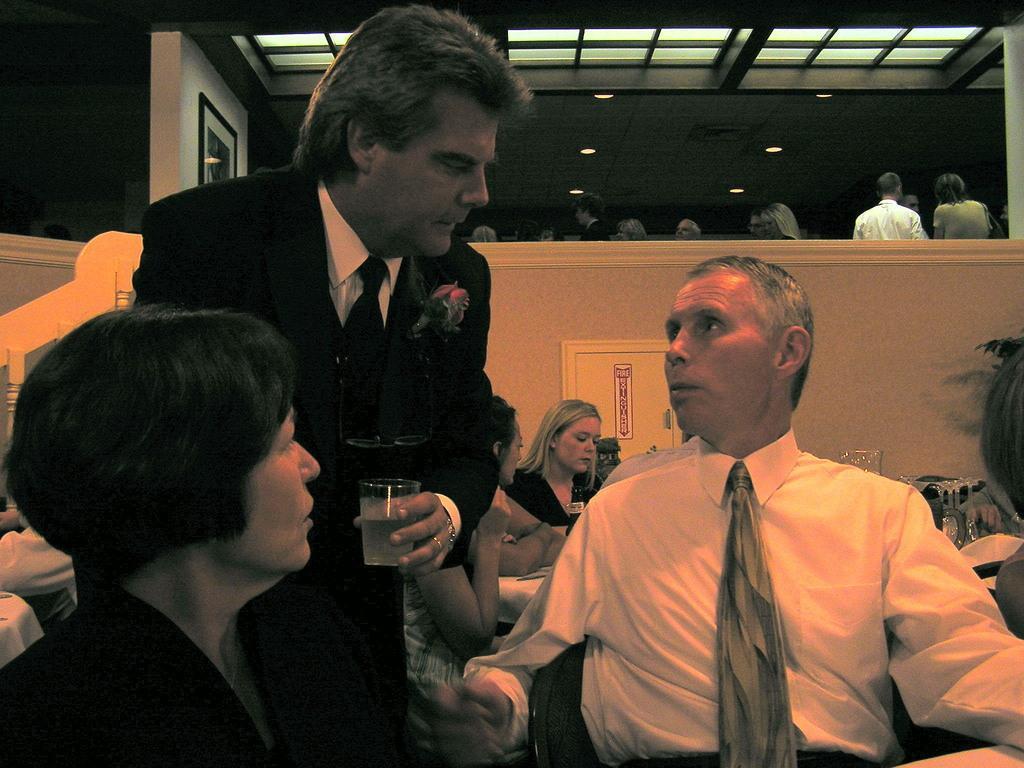Can you describe this image briefly? In the picture we can see a man and a woman sitting on the chairs and between them we can see a man standing and holding a glass with water and he is in blazer, tie and shirt and a man who is sitting looking at him and behind them, we can see some women are also sitting near the table and behind them we can see a wall and behind the wall we can see some people are standing and to the ceiling we can see some lights. 